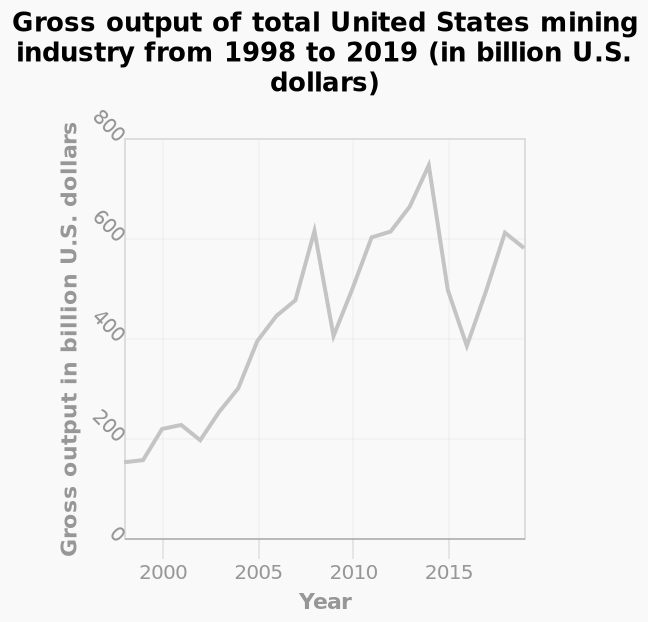<image>
What does the line plot show?  The line plot shows the gross output of the total United States mining industry from 1998 to 2019 in billion U.S. dollars. What is the minimum value on the y-axis? The minimum value on the y-axis is 0 billion U.S. dollars. 